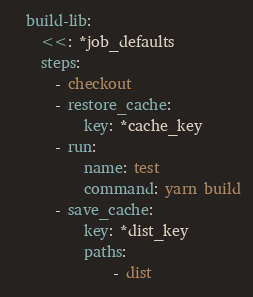<code> <loc_0><loc_0><loc_500><loc_500><_YAML_>
  build-lib:
    <<: *job_defaults
    steps:
      - checkout
      - restore_cache:
          key: *cache_key
      - run:
          name: test
          command: yarn build
      - save_cache:
          key: *dist_key
          paths:
              - dist
</code> 